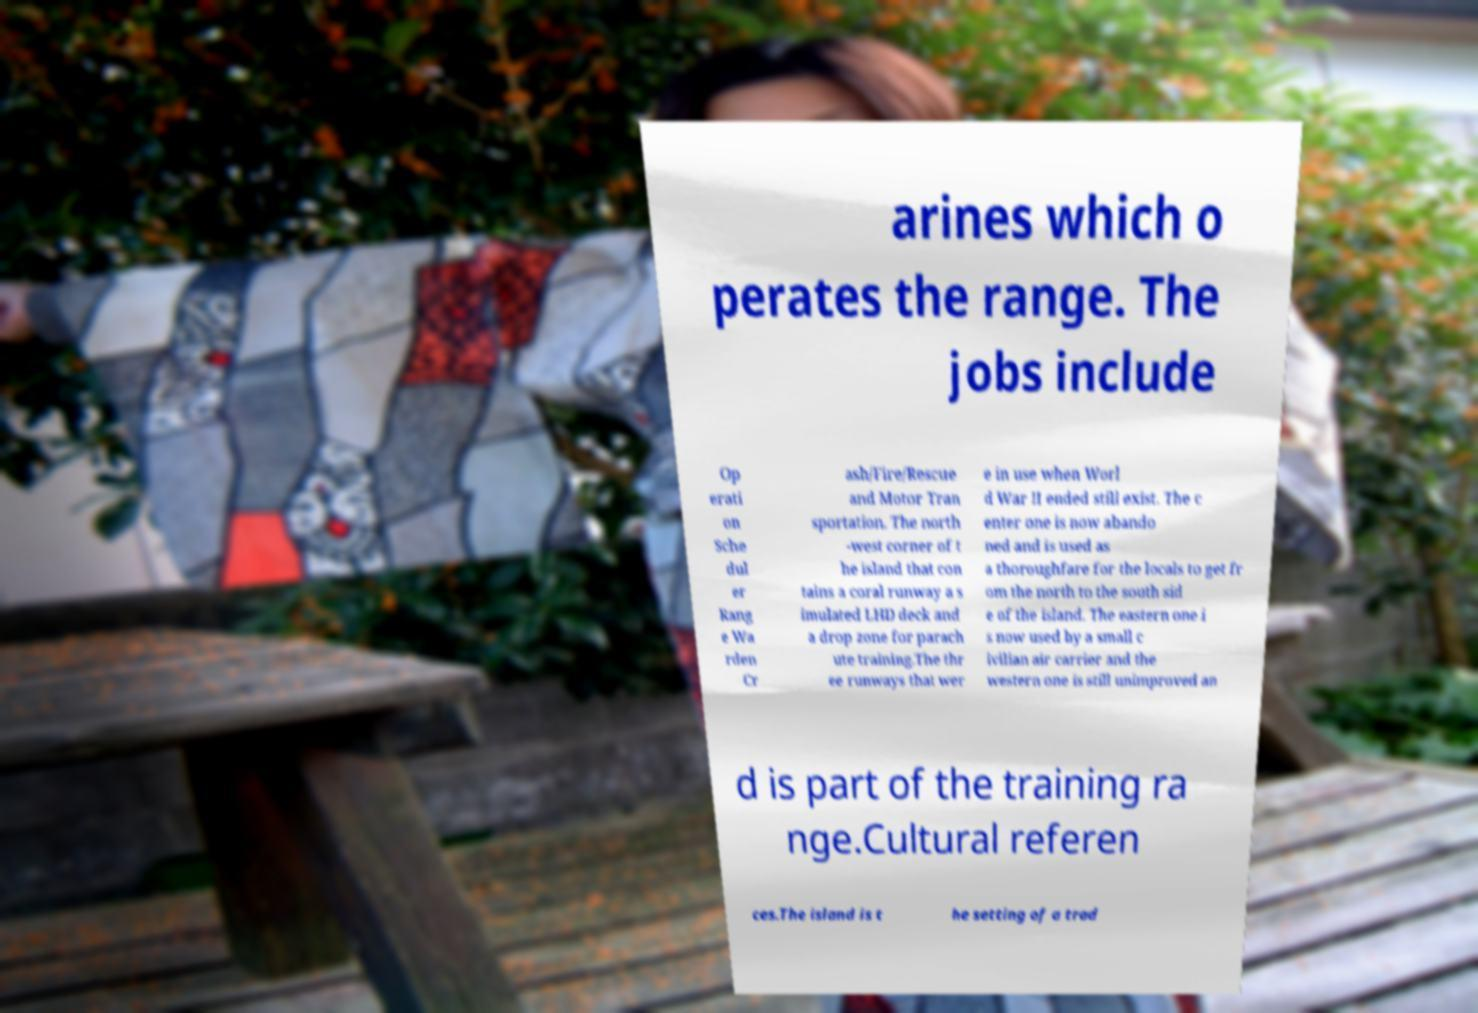Please identify and transcribe the text found in this image. arines which o perates the range. The jobs include Op erati on Sche dul er Rang e Wa rden Cr ash/Fire/Rescue and Motor Tran sportation. The north -west corner of t he island that con tains a coral runway a s imulated LHD deck and a drop zone for parach ute training.The thr ee runways that wer e in use when Worl d War II ended still exist. The c enter one is now abando ned and is used as a thoroughfare for the locals to get fr om the north to the south sid e of the island. The eastern one i s now used by a small c ivilian air carrier and the western one is still unimproved an d is part of the training ra nge.Cultural referen ces.The island is t he setting of a trad 